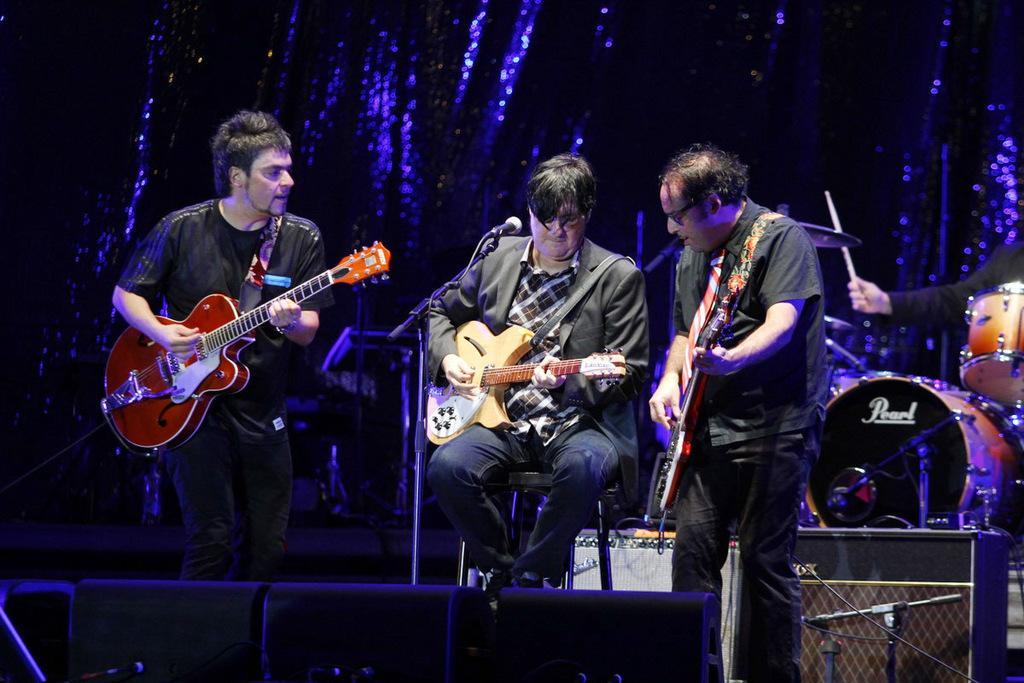Please provide a concise description of this image. In this image there are three persons. In middle the person is sitting and playing a musical instrument. There is a mic and stand. 